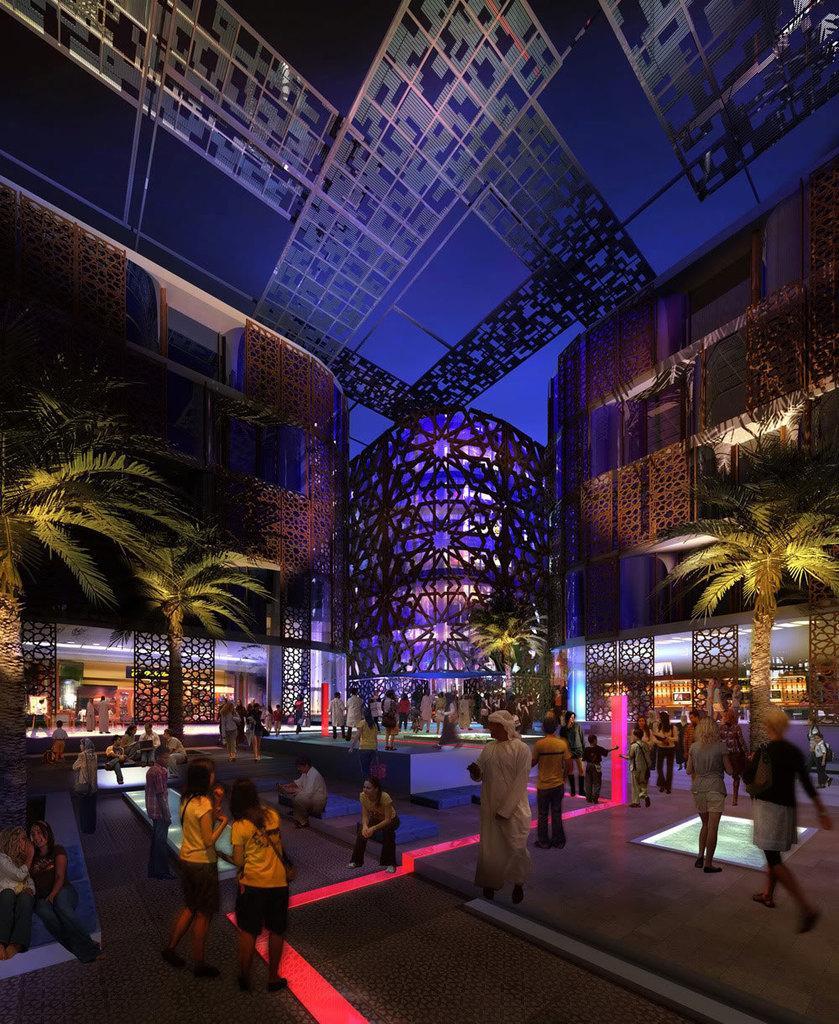Please provide a concise description of this image. This image is clicked outside. There is building in the middle. There are trees in the middle. There are some persons at the bottom. 